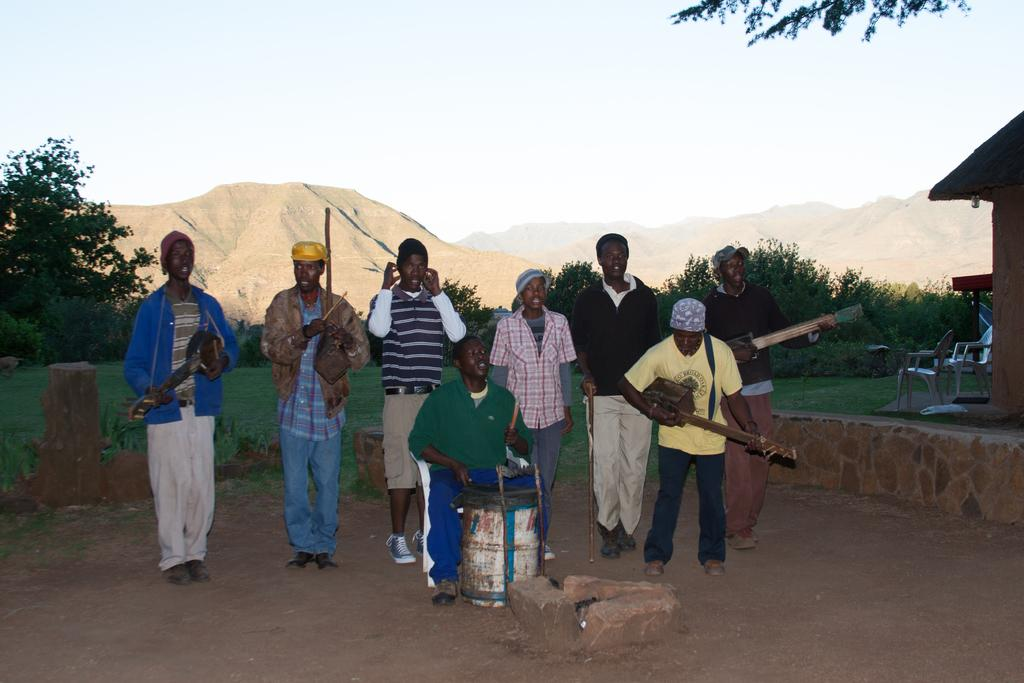What are the people in the image doing? The people in the image are holding musical instruments. What type of natural environment is visible in the image? There are trees and grass in the image. What architectural features can be seen in the image? There are pillars and a house in the image. What is visible in the background of the image? The sky is visible in the background of the image. What type of seating is present in the image? There are chairs in the image. Where is the waste container located in the image? There is no waste container present in the image. What type of arch can be seen in the image? There is no arch present in the image. 